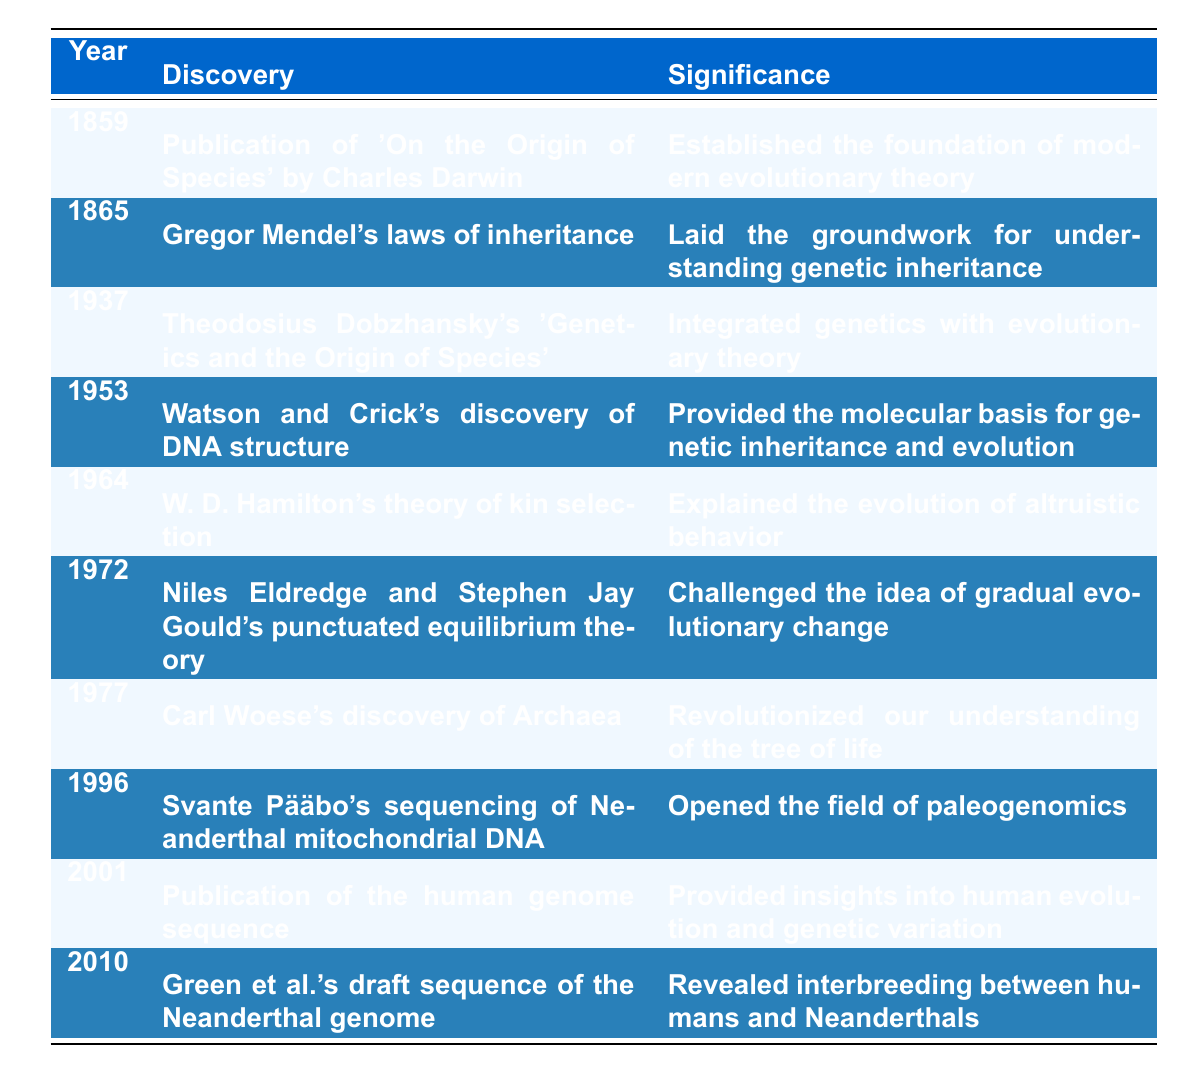What year did Darwin publish 'On the Origin of Species'? According to the table, the year listed for the publication of 'On the Origin of Species' by Charles Darwin is 1859.
Answer: 1859 What is the significance of Mendel's laws of inheritance? The table states that the significance of Gregor Mendel's laws of inheritance is that it laid the groundwork for understanding genetic inheritance.
Answer: Laid the groundwork for understanding genetic inheritance Which discovery occurred in 1953? Looking at the table, the discovery listed for the year 1953 is Watson and Crick's discovery of DNA structure.
Answer: Watson and Crick's discovery of DNA structure In what year was the sequencing of Neanderthal mitochondrial DNA completed? According to the table, the sequencing of Neanderthal mitochondrial DNA by Svante Pääbo was completed in 1996.
Answer: 1996 How many discoveries listed in the table took place in the 20th century (1900-1999)? The table lists discoveries in the years 1937, 1953, 1964, 1972, 1977, and 1996. There are 6 discoveries in total within the 20th century.
Answer: 6 What discovery challenged the idea of gradual evolutionary change? The table indicates that Niles Eldredge and Stephen Jay Gould's punctuated equilibrium theory, discovered in 1972, challenged the idea of gradual evolutionary change.
Answer: Punctuated equilibrium theory Was the discovery of the structure of DNA significant? Yes, the table confirms that Watson and Crick's discovery of DNA structure in 1953 provided the molecular basis for genetic inheritance and evolution, indicating its significance.
Answer: Yes Which two discoveries were made in the same century and relate to our understanding of human evolution? The discoveries made in the 20th century related to human evolution are Svante Pääbo's sequencing of Neanderthal mitochondrial DNA in 1996 and the publication of the human genome sequence in 2001, both of which provide insights into human evolution and genetic variation.
Answer: 1996 and 2001 What is the earliest discovery listed in the timeline? The earliest discovery listed in the timeline is the publication of 'On the Origin of Species' by Charles Darwin in 1859.
Answer: 1859 Which discovery indicates evidence of interbreeding between humans and Neanderthals? The table shows that the discovery made in 2010, the draft sequence of the Neanderthal genome by Green et al., revealed interbreeding between humans and Neanderthals.
Answer: Draft sequence of the Neanderthal genome 